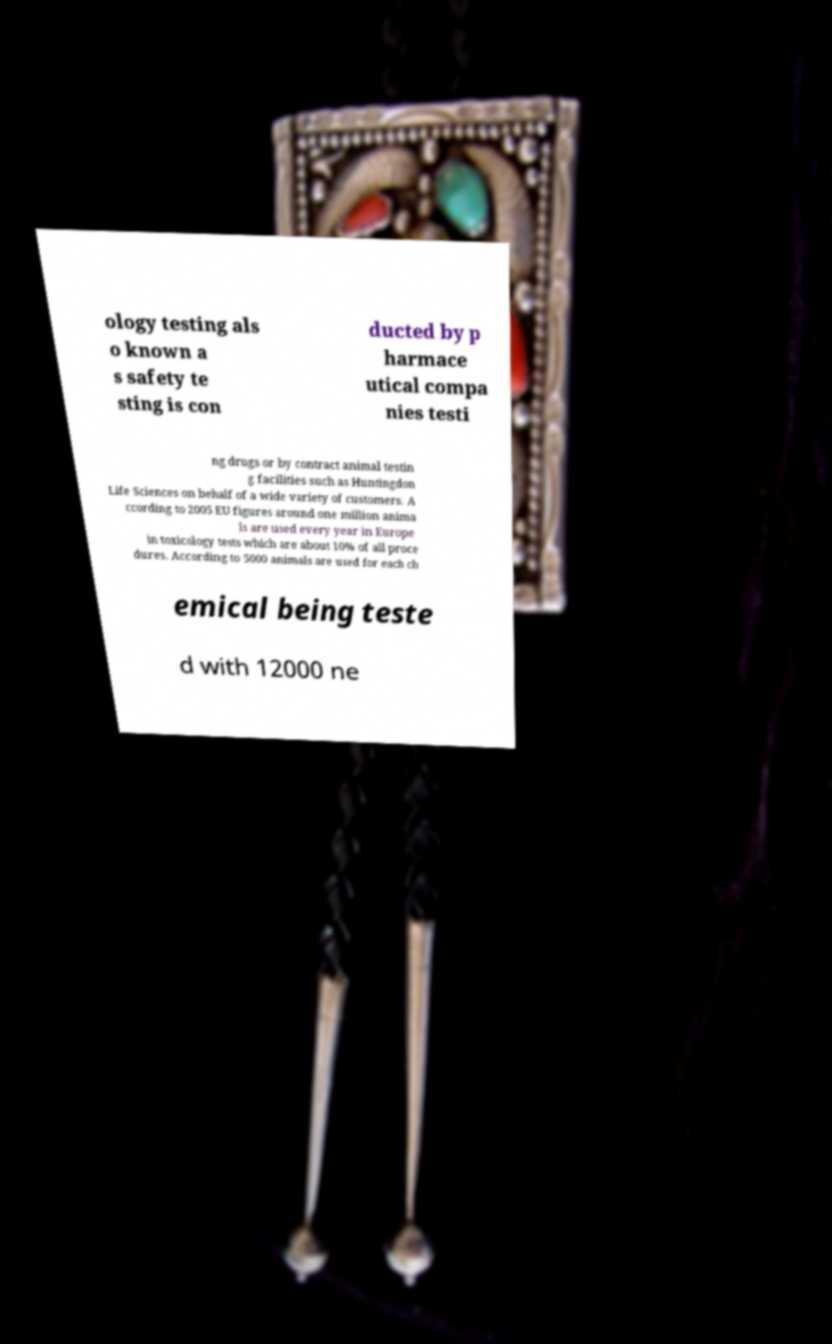Can you read and provide the text displayed in the image?This photo seems to have some interesting text. Can you extract and type it out for me? ology testing als o known a s safety te sting is con ducted by p harmace utical compa nies testi ng drugs or by contract animal testin g facilities such as Huntingdon Life Sciences on behalf of a wide variety of customers. A ccording to 2005 EU figures around one million anima ls are used every year in Europe in toxicology tests which are about 10% of all proce dures. According to 5000 animals are used for each ch emical being teste d with 12000 ne 